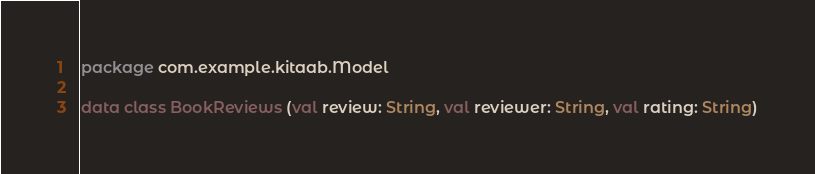Convert code to text. <code><loc_0><loc_0><loc_500><loc_500><_Kotlin_>package com.example.kitaab.Model

data class BookReviews (val review: String, val reviewer: String, val rating: String)</code> 